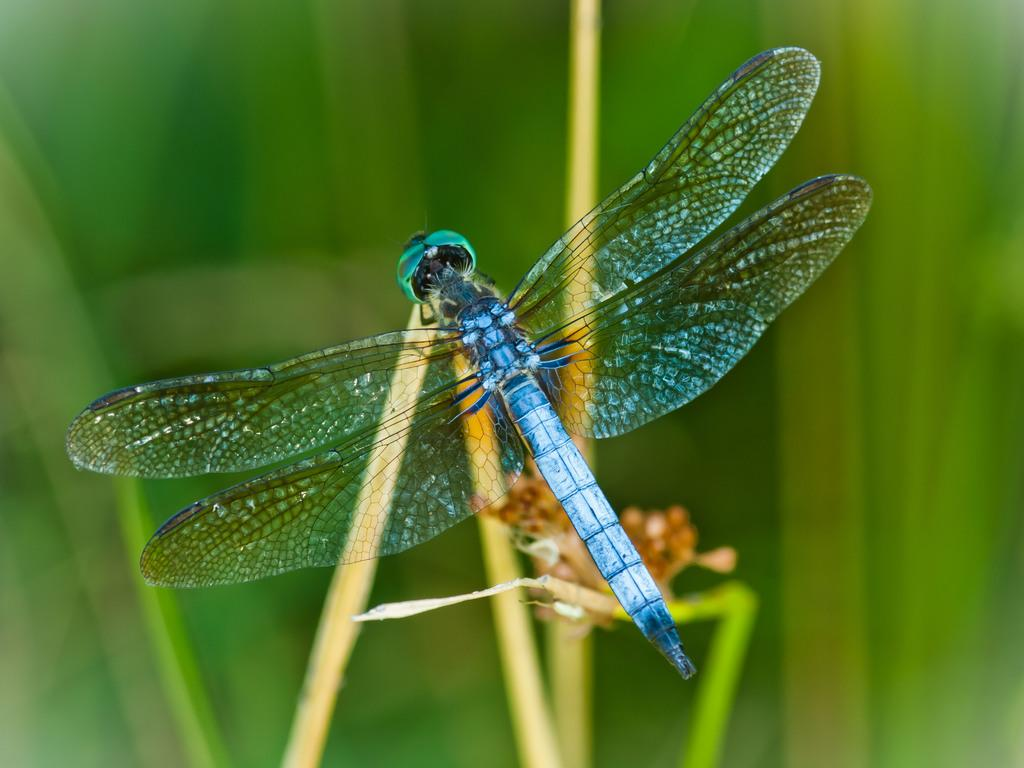What is present in the image? There is an insect in the image. Where is the insect located? The insect is on the stem of a plant. What type of fang can be seen on the insect in the image? There is no fang visible on the insect in the image. How does the insect transport itself in the image? The insect does not transport itself in the image; it is stationary on the stem of the plant. 